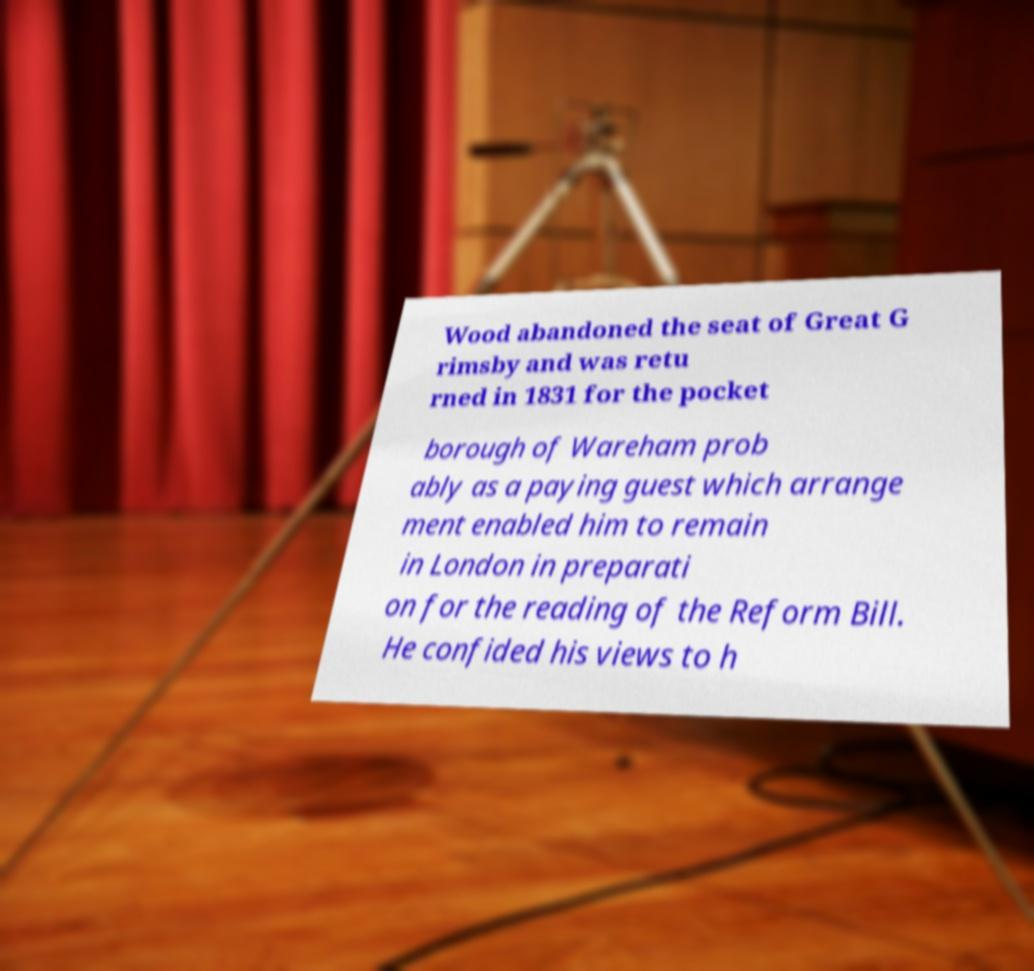Can you read and provide the text displayed in the image?This photo seems to have some interesting text. Can you extract and type it out for me? Wood abandoned the seat of Great G rimsby and was retu rned in 1831 for the pocket borough of Wareham prob ably as a paying guest which arrange ment enabled him to remain in London in preparati on for the reading of the Reform Bill. He confided his views to h 